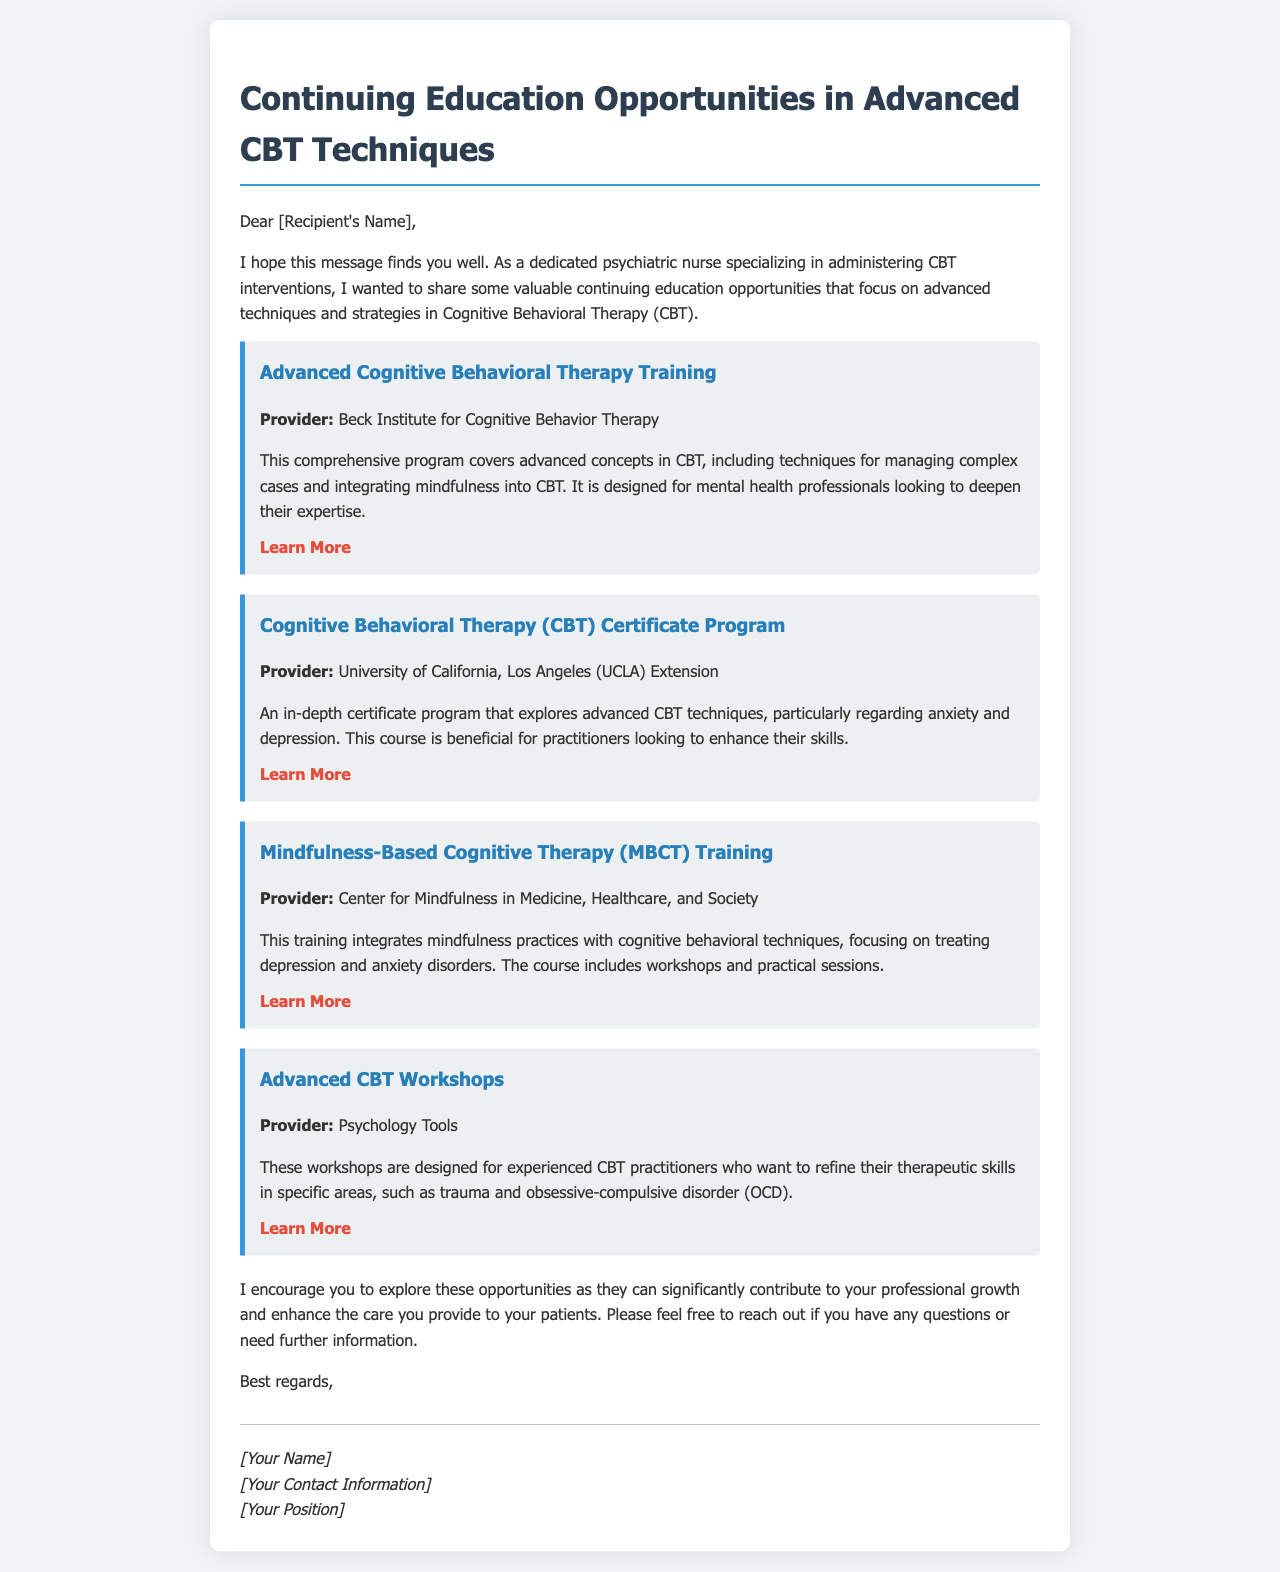What is the first opportunity listed? The first opportunity is titled "Advanced Cognitive Behavioral Therapy Training."
Answer: Advanced Cognitive Behavioral Therapy Training Who provides the CBT Certificate Program? The document states that the program is provided by the University of California, Los Angeles (UCLA) Extension.
Answer: University of California, Los Angeles (UCLA) Extension What training integrates mindfulness with CBT? The training that combines mindfulness practices with CBT is called Mindfulness-Based Cognitive Therapy (MBCT) Training.
Answer: Mindfulness-Based Cognitive Therapy (MBCT) Training Which provider offers Advanced CBT Workshops? The provider for the Advanced CBT Workshops is Psychology Tools.
Answer: Psychology Tools How many opportunities are mentioned in the document? The document lists four distinct opportunities focused on advanced CBT techniques.
Answer: Four 